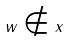<formula> <loc_0><loc_0><loc_500><loc_500>w \notin x</formula> 